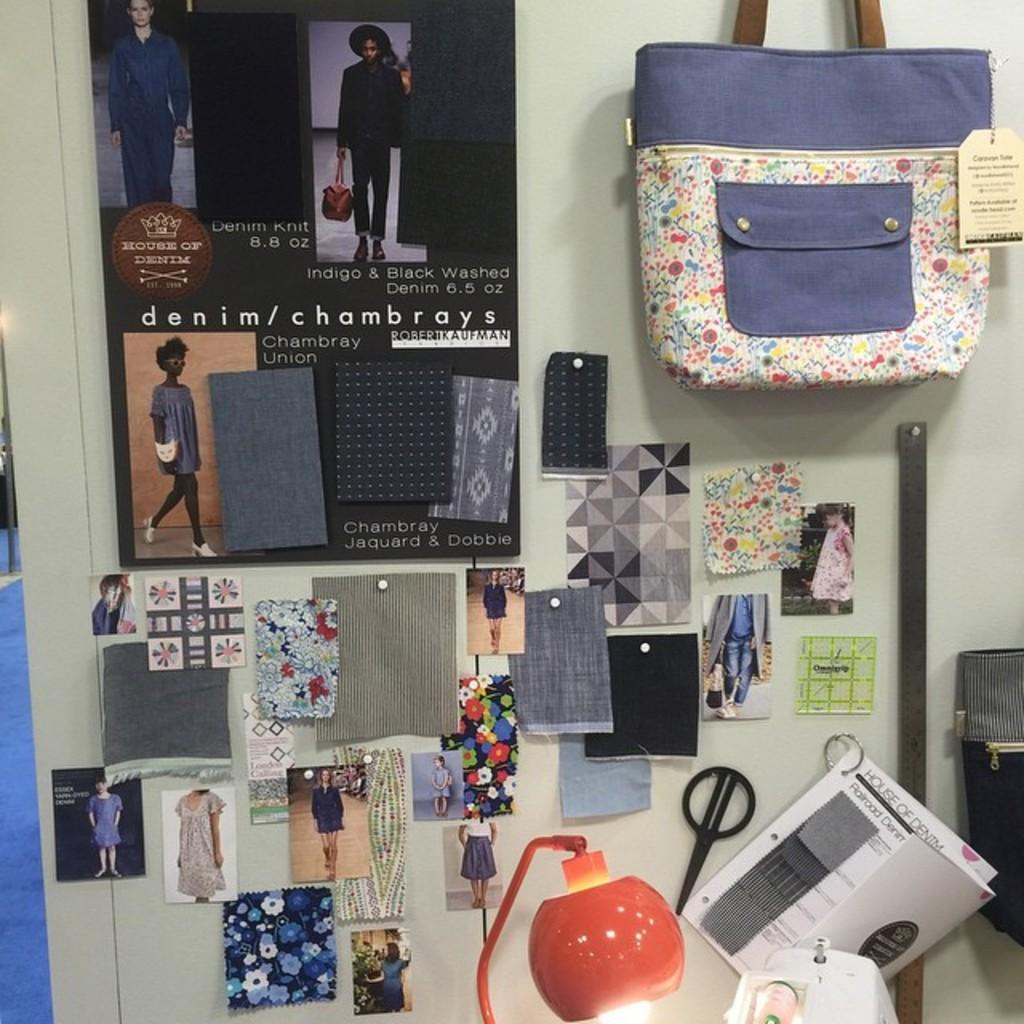What is hanging on the wall in the image? There is a poster and photos on the wall in the image. What else can be seen on the wall besides the poster and photos? There is a handbag on the wall. What type of light source is present in the image? There is a lamp in the image. What type of paper items are visible in the image? There are papers in the image. Where is the bucket located in the image? There is no bucket present in the image. What type of patch can be seen on the wall in the image? There is no patch visible on the wall in the image. 